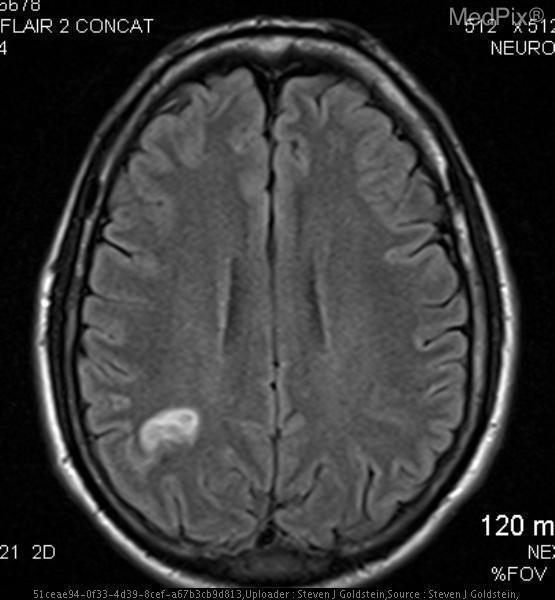What side of the brain is the lesion on?
Be succinct. Right. Where in the brain is the lesion?
Quick response, please. Right parietal lobe. Where is the lesion?
Be succinct. Right parietal lobe. What is the image suggestive of?
Concise answer only. Abscess. What is the lesion most likely to be?
Short answer required. Abscess. Is there evidence of enhancement?
Short answer required. Yes. Is the lesion enhancing?
Answer briefly. Yes. 